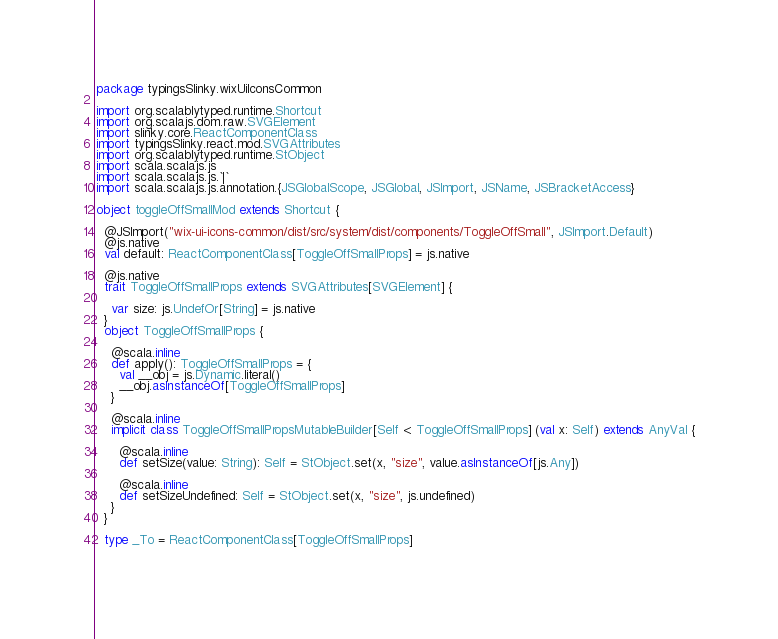Convert code to text. <code><loc_0><loc_0><loc_500><loc_500><_Scala_>package typingsSlinky.wixUiIconsCommon

import org.scalablytyped.runtime.Shortcut
import org.scalajs.dom.raw.SVGElement
import slinky.core.ReactComponentClass
import typingsSlinky.react.mod.SVGAttributes
import org.scalablytyped.runtime.StObject
import scala.scalajs.js
import scala.scalajs.js.`|`
import scala.scalajs.js.annotation.{JSGlobalScope, JSGlobal, JSImport, JSName, JSBracketAccess}

object toggleOffSmallMod extends Shortcut {
  
  @JSImport("wix-ui-icons-common/dist/src/system/dist/components/ToggleOffSmall", JSImport.Default)
  @js.native
  val default: ReactComponentClass[ToggleOffSmallProps] = js.native
  
  @js.native
  trait ToggleOffSmallProps extends SVGAttributes[SVGElement] {
    
    var size: js.UndefOr[String] = js.native
  }
  object ToggleOffSmallProps {
    
    @scala.inline
    def apply(): ToggleOffSmallProps = {
      val __obj = js.Dynamic.literal()
      __obj.asInstanceOf[ToggleOffSmallProps]
    }
    
    @scala.inline
    implicit class ToggleOffSmallPropsMutableBuilder[Self <: ToggleOffSmallProps] (val x: Self) extends AnyVal {
      
      @scala.inline
      def setSize(value: String): Self = StObject.set(x, "size", value.asInstanceOf[js.Any])
      
      @scala.inline
      def setSizeUndefined: Self = StObject.set(x, "size", js.undefined)
    }
  }
  
  type _To = ReactComponentClass[ToggleOffSmallProps]
  </code> 